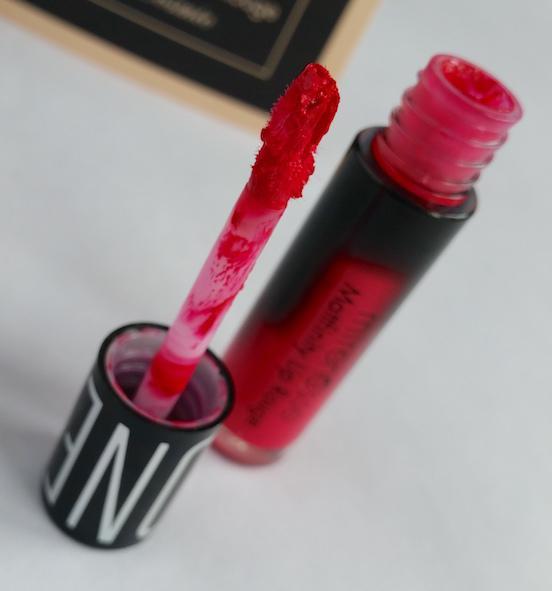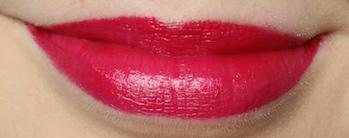The first image is the image on the left, the second image is the image on the right. Analyze the images presented: Is the assertion "There are no tinted lips in the left image only." valid? Answer yes or no. Yes. 